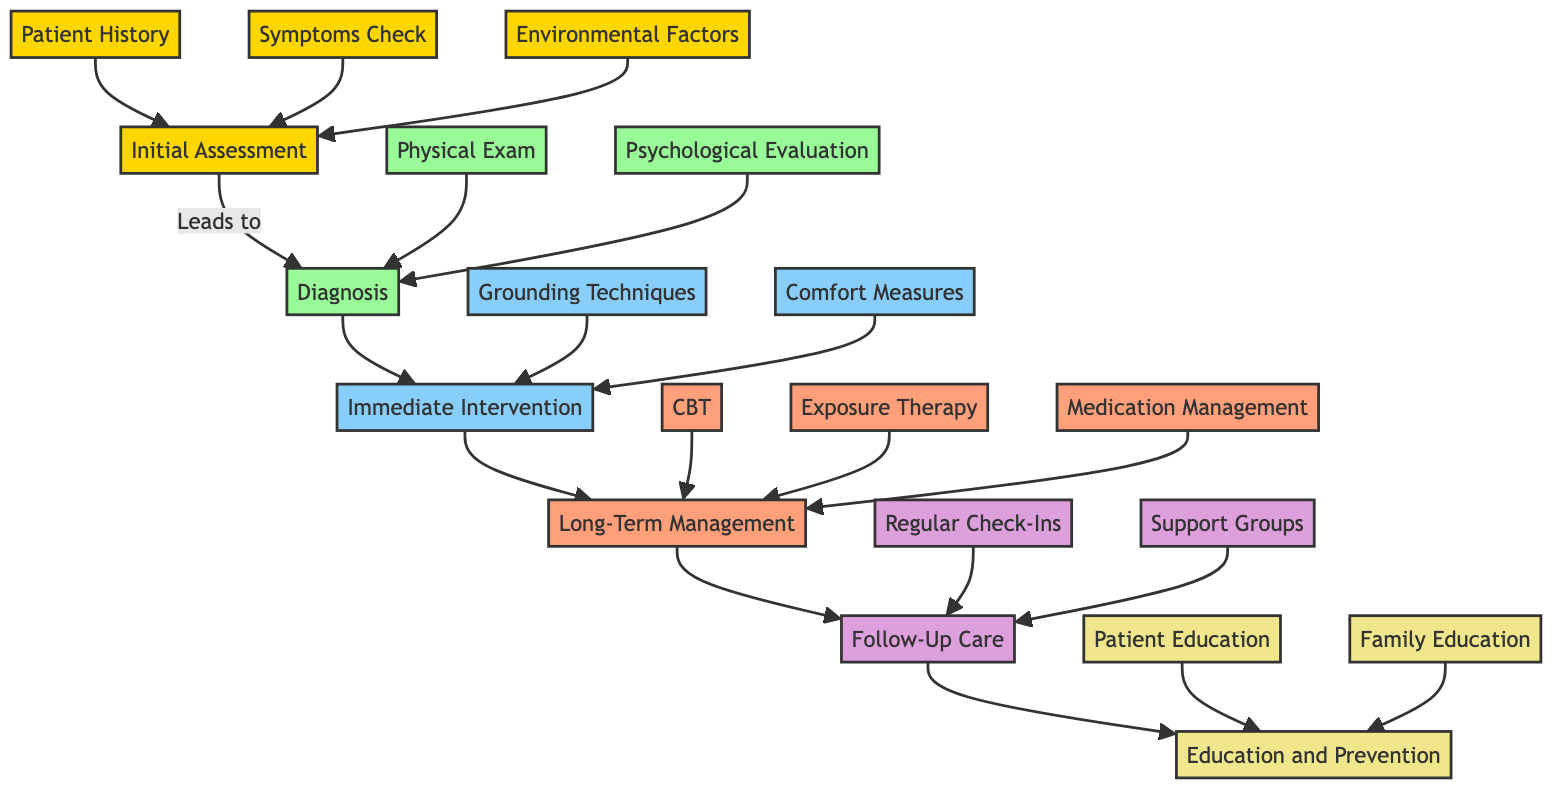What are the three main components in the Initial Assessment? The Initial Assessment comprises Patient History, Symptoms Check, and Environmental Factors. Each of these components is visually represented in the diagram as leading to the Diagnosis.
Answer: Patient History, Symptoms Check, Environmental Factors How many types of immediate interventions are there? The diagram shows two types of immediate interventions: Grounding Techniques and Comfort Measures. Both are part of the Immediate Intervention node leading to Long-Term Management.
Answer: 2 Which long-term management technique involves gradual exposure? Exposure Therapy is the technique that involves gradual, controlled exposure to fears related to ghostly experiences. This is directly connected to the Long-Term Management node in the diagram.
Answer: Exposure Therapy What is the last component mentioned in the Clinical Pathway? The Education and Prevention is the last component mentioned in the Clinical Pathway. It appears after Follow-Up Care, illustrating the progression of treatment and support methods.
Answer: Education and Prevention Which node directly leads to Follow-Up Care? The Long-Term Management node directly leads to Follow-Up Care, indicating a continuation of care after implementing long-term strategies.
Answer: Long-Term Management What type of therapy is suggested for addressing irrational fears? Cognitive Behavioral Therapy (CBT) is suggested for addressing irrational fears and catastrophic thinking within the Long-Term Management component.
Answer: Cognitive Behavioral Therapy How many follow-up care strategies are outlined? The diagram outlines two follow-up care strategies: Regular Check-Ins and Support Groups, which are both part of the Follow-Up Care node.
Answer: 2 What should family members be educated about? Family Education involves involving family members in understanding and supporting the patient, and it is part of the Education and Prevention component in the pathway.
Answer: Understanding and supporting the patient 